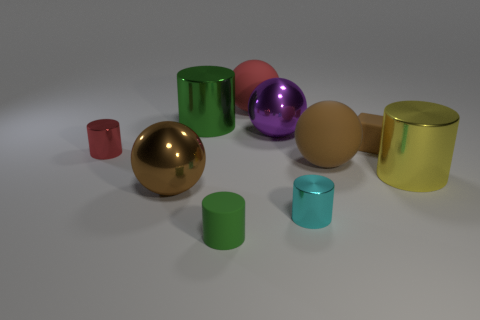Subtract 2 cylinders. How many cylinders are left? 3 Subtract all gray cylinders. Subtract all cyan spheres. How many cylinders are left? 5 Subtract all spheres. How many objects are left? 6 Subtract 0 yellow blocks. How many objects are left? 10 Subtract all small red rubber cylinders. Subtract all shiny spheres. How many objects are left? 8 Add 7 big shiny spheres. How many big shiny spheres are left? 9 Add 8 large gray matte objects. How many large gray matte objects exist? 8 